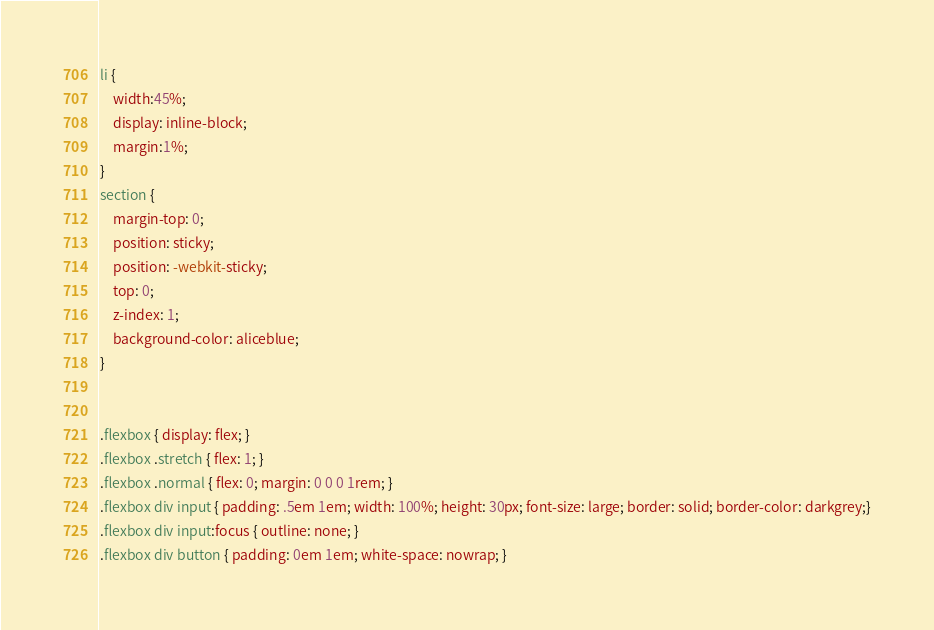Convert code to text. <code><loc_0><loc_0><loc_500><loc_500><_CSS_>li {
    width:45%;
    display: inline-block;
    margin:1%;
}
section {
    margin-top: 0;
    position: sticky;
    position: -webkit-sticky;
    top: 0;
    z-index: 1;
    background-color: aliceblue;
}


.flexbox { display: flex; }
.flexbox .stretch { flex: 1; }
.flexbox .normal { flex: 0; margin: 0 0 0 1rem; }
.flexbox div input { padding: .5em 1em; width: 100%; height: 30px; font-size: large; border: solid; border-color: darkgrey;}
.flexbox div input:focus { outline: none; }
.flexbox div button { padding: 0em 1em; white-space: nowrap; }</code> 